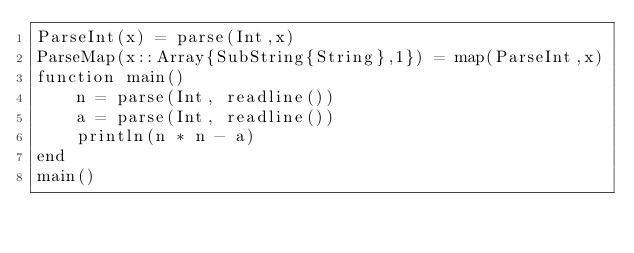Convert code to text. <code><loc_0><loc_0><loc_500><loc_500><_Julia_>ParseInt(x) = parse(Int,x)
ParseMap(x::Array{SubString{String},1}) = map(ParseInt,x)
function main()
    n = parse(Int, readline())
    a = parse(Int, readline())
    println(n * n - a)
end
main()</code> 